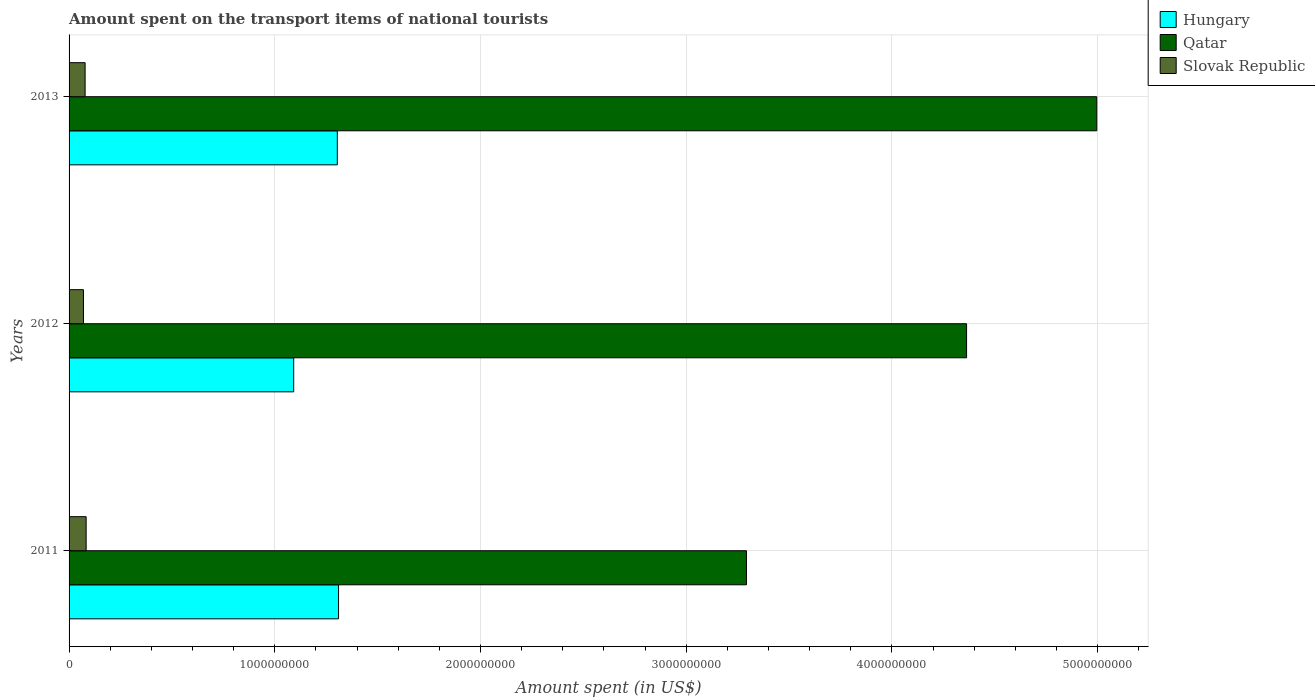How many different coloured bars are there?
Provide a succinct answer. 3. How many groups of bars are there?
Offer a terse response. 3. Are the number of bars per tick equal to the number of legend labels?
Ensure brevity in your answer.  Yes. What is the label of the 3rd group of bars from the top?
Make the answer very short. 2011. What is the amount spent on the transport items of national tourists in Qatar in 2011?
Provide a succinct answer. 3.29e+09. Across all years, what is the maximum amount spent on the transport items of national tourists in Hungary?
Offer a terse response. 1.31e+09. Across all years, what is the minimum amount spent on the transport items of national tourists in Slovak Republic?
Your response must be concise. 7.00e+07. What is the total amount spent on the transport items of national tourists in Qatar in the graph?
Your answer should be very brief. 1.27e+1. What is the difference between the amount spent on the transport items of national tourists in Slovak Republic in 2011 and that in 2013?
Ensure brevity in your answer.  5.00e+06. What is the difference between the amount spent on the transport items of national tourists in Hungary in 2011 and the amount spent on the transport items of national tourists in Qatar in 2013?
Provide a short and direct response. -3.69e+09. What is the average amount spent on the transport items of national tourists in Hungary per year?
Keep it short and to the point. 1.24e+09. In the year 2012, what is the difference between the amount spent on the transport items of national tourists in Qatar and amount spent on the transport items of national tourists in Slovak Republic?
Make the answer very short. 4.29e+09. What is the ratio of the amount spent on the transport items of national tourists in Hungary in 2011 to that in 2013?
Your answer should be compact. 1. What is the difference between the highest and the second highest amount spent on the transport items of national tourists in Qatar?
Your answer should be compact. 6.33e+08. What is the difference between the highest and the lowest amount spent on the transport items of national tourists in Slovak Republic?
Your response must be concise. 1.30e+07. What does the 2nd bar from the top in 2011 represents?
Give a very brief answer. Qatar. What does the 3rd bar from the bottom in 2012 represents?
Give a very brief answer. Slovak Republic. Is it the case that in every year, the sum of the amount spent on the transport items of national tourists in Qatar and amount spent on the transport items of national tourists in Hungary is greater than the amount spent on the transport items of national tourists in Slovak Republic?
Keep it short and to the point. Yes. Are all the bars in the graph horizontal?
Offer a very short reply. Yes. What is the difference between two consecutive major ticks on the X-axis?
Your answer should be compact. 1.00e+09. Are the values on the major ticks of X-axis written in scientific E-notation?
Ensure brevity in your answer.  No. Does the graph contain any zero values?
Provide a short and direct response. No. Does the graph contain grids?
Your answer should be very brief. Yes. What is the title of the graph?
Your answer should be compact. Amount spent on the transport items of national tourists. Does "Cuba" appear as one of the legend labels in the graph?
Offer a very short reply. No. What is the label or title of the X-axis?
Offer a very short reply. Amount spent (in US$). What is the Amount spent (in US$) in Hungary in 2011?
Give a very brief answer. 1.31e+09. What is the Amount spent (in US$) in Qatar in 2011?
Keep it short and to the point. 3.29e+09. What is the Amount spent (in US$) of Slovak Republic in 2011?
Offer a very short reply. 8.30e+07. What is the Amount spent (in US$) in Hungary in 2012?
Ensure brevity in your answer.  1.09e+09. What is the Amount spent (in US$) in Qatar in 2012?
Your answer should be compact. 4.36e+09. What is the Amount spent (in US$) in Slovak Republic in 2012?
Keep it short and to the point. 7.00e+07. What is the Amount spent (in US$) of Hungary in 2013?
Offer a very short reply. 1.30e+09. What is the Amount spent (in US$) in Qatar in 2013?
Your response must be concise. 5.00e+09. What is the Amount spent (in US$) in Slovak Republic in 2013?
Offer a very short reply. 7.80e+07. Across all years, what is the maximum Amount spent (in US$) of Hungary?
Ensure brevity in your answer.  1.31e+09. Across all years, what is the maximum Amount spent (in US$) in Qatar?
Make the answer very short. 5.00e+09. Across all years, what is the maximum Amount spent (in US$) in Slovak Republic?
Your response must be concise. 8.30e+07. Across all years, what is the minimum Amount spent (in US$) in Hungary?
Offer a terse response. 1.09e+09. Across all years, what is the minimum Amount spent (in US$) of Qatar?
Your answer should be compact. 3.29e+09. Across all years, what is the minimum Amount spent (in US$) in Slovak Republic?
Keep it short and to the point. 7.00e+07. What is the total Amount spent (in US$) of Hungary in the graph?
Ensure brevity in your answer.  3.71e+09. What is the total Amount spent (in US$) of Qatar in the graph?
Give a very brief answer. 1.27e+1. What is the total Amount spent (in US$) of Slovak Republic in the graph?
Provide a short and direct response. 2.31e+08. What is the difference between the Amount spent (in US$) in Hungary in 2011 and that in 2012?
Provide a short and direct response. 2.18e+08. What is the difference between the Amount spent (in US$) of Qatar in 2011 and that in 2012?
Your answer should be very brief. -1.07e+09. What is the difference between the Amount spent (in US$) of Slovak Republic in 2011 and that in 2012?
Ensure brevity in your answer.  1.30e+07. What is the difference between the Amount spent (in US$) in Qatar in 2011 and that in 2013?
Ensure brevity in your answer.  -1.70e+09. What is the difference between the Amount spent (in US$) in Slovak Republic in 2011 and that in 2013?
Give a very brief answer. 5.00e+06. What is the difference between the Amount spent (in US$) of Hungary in 2012 and that in 2013?
Ensure brevity in your answer.  -2.12e+08. What is the difference between the Amount spent (in US$) of Qatar in 2012 and that in 2013?
Your answer should be very brief. -6.33e+08. What is the difference between the Amount spent (in US$) in Slovak Republic in 2012 and that in 2013?
Ensure brevity in your answer.  -8.00e+06. What is the difference between the Amount spent (in US$) of Hungary in 2011 and the Amount spent (in US$) of Qatar in 2012?
Give a very brief answer. -3.05e+09. What is the difference between the Amount spent (in US$) of Hungary in 2011 and the Amount spent (in US$) of Slovak Republic in 2012?
Offer a terse response. 1.24e+09. What is the difference between the Amount spent (in US$) in Qatar in 2011 and the Amount spent (in US$) in Slovak Republic in 2012?
Keep it short and to the point. 3.22e+09. What is the difference between the Amount spent (in US$) in Hungary in 2011 and the Amount spent (in US$) in Qatar in 2013?
Provide a succinct answer. -3.69e+09. What is the difference between the Amount spent (in US$) in Hungary in 2011 and the Amount spent (in US$) in Slovak Republic in 2013?
Make the answer very short. 1.23e+09. What is the difference between the Amount spent (in US$) in Qatar in 2011 and the Amount spent (in US$) in Slovak Republic in 2013?
Provide a succinct answer. 3.22e+09. What is the difference between the Amount spent (in US$) in Hungary in 2012 and the Amount spent (in US$) in Qatar in 2013?
Your answer should be very brief. -3.90e+09. What is the difference between the Amount spent (in US$) of Hungary in 2012 and the Amount spent (in US$) of Slovak Republic in 2013?
Ensure brevity in your answer.  1.01e+09. What is the difference between the Amount spent (in US$) in Qatar in 2012 and the Amount spent (in US$) in Slovak Republic in 2013?
Your response must be concise. 4.28e+09. What is the average Amount spent (in US$) in Hungary per year?
Offer a very short reply. 1.24e+09. What is the average Amount spent (in US$) in Qatar per year?
Your answer should be very brief. 4.22e+09. What is the average Amount spent (in US$) in Slovak Republic per year?
Your answer should be very brief. 7.70e+07. In the year 2011, what is the difference between the Amount spent (in US$) in Hungary and Amount spent (in US$) in Qatar?
Offer a terse response. -1.98e+09. In the year 2011, what is the difference between the Amount spent (in US$) of Hungary and Amount spent (in US$) of Slovak Republic?
Keep it short and to the point. 1.23e+09. In the year 2011, what is the difference between the Amount spent (in US$) in Qatar and Amount spent (in US$) in Slovak Republic?
Provide a short and direct response. 3.21e+09. In the year 2012, what is the difference between the Amount spent (in US$) of Hungary and Amount spent (in US$) of Qatar?
Offer a very short reply. -3.27e+09. In the year 2012, what is the difference between the Amount spent (in US$) in Hungary and Amount spent (in US$) in Slovak Republic?
Your response must be concise. 1.02e+09. In the year 2012, what is the difference between the Amount spent (in US$) in Qatar and Amount spent (in US$) in Slovak Republic?
Make the answer very short. 4.29e+09. In the year 2013, what is the difference between the Amount spent (in US$) in Hungary and Amount spent (in US$) in Qatar?
Give a very brief answer. -3.69e+09. In the year 2013, what is the difference between the Amount spent (in US$) of Hungary and Amount spent (in US$) of Slovak Republic?
Your answer should be compact. 1.23e+09. In the year 2013, what is the difference between the Amount spent (in US$) in Qatar and Amount spent (in US$) in Slovak Republic?
Make the answer very short. 4.92e+09. What is the ratio of the Amount spent (in US$) of Hungary in 2011 to that in 2012?
Offer a very short reply. 1.2. What is the ratio of the Amount spent (in US$) in Qatar in 2011 to that in 2012?
Your response must be concise. 0.75. What is the ratio of the Amount spent (in US$) in Slovak Republic in 2011 to that in 2012?
Ensure brevity in your answer.  1.19. What is the ratio of the Amount spent (in US$) in Qatar in 2011 to that in 2013?
Keep it short and to the point. 0.66. What is the ratio of the Amount spent (in US$) of Slovak Republic in 2011 to that in 2013?
Provide a succinct answer. 1.06. What is the ratio of the Amount spent (in US$) in Hungary in 2012 to that in 2013?
Ensure brevity in your answer.  0.84. What is the ratio of the Amount spent (in US$) in Qatar in 2012 to that in 2013?
Your answer should be very brief. 0.87. What is the ratio of the Amount spent (in US$) of Slovak Republic in 2012 to that in 2013?
Keep it short and to the point. 0.9. What is the difference between the highest and the second highest Amount spent (in US$) in Qatar?
Ensure brevity in your answer.  6.33e+08. What is the difference between the highest and the second highest Amount spent (in US$) of Slovak Republic?
Ensure brevity in your answer.  5.00e+06. What is the difference between the highest and the lowest Amount spent (in US$) in Hungary?
Ensure brevity in your answer.  2.18e+08. What is the difference between the highest and the lowest Amount spent (in US$) of Qatar?
Your answer should be very brief. 1.70e+09. What is the difference between the highest and the lowest Amount spent (in US$) in Slovak Republic?
Your answer should be compact. 1.30e+07. 